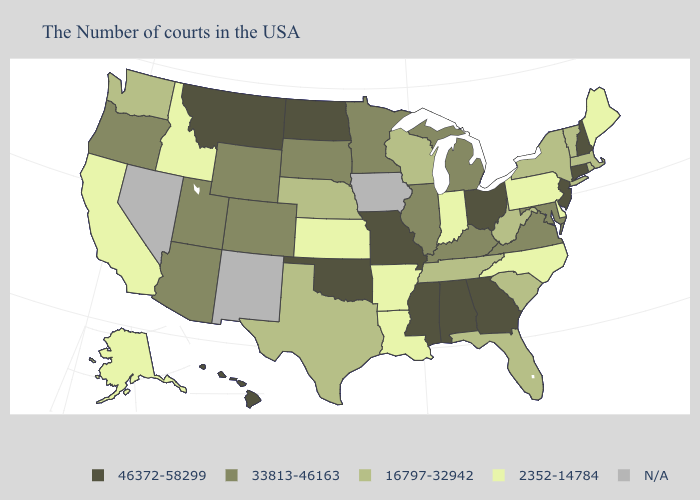Name the states that have a value in the range N/A?
Give a very brief answer. Iowa, New Mexico, Nevada. What is the value of Tennessee?
Quick response, please. 16797-32942. What is the lowest value in states that border Florida?
Concise answer only. 46372-58299. What is the value of Michigan?
Be succinct. 33813-46163. What is the value of Delaware?
Give a very brief answer. 2352-14784. Which states hav the highest value in the South?
Short answer required. Georgia, Alabama, Mississippi, Oklahoma. Name the states that have a value in the range 46372-58299?
Quick response, please. New Hampshire, Connecticut, New Jersey, Ohio, Georgia, Alabama, Mississippi, Missouri, Oklahoma, North Dakota, Montana, Hawaii. What is the highest value in states that border North Carolina?
Answer briefly. 46372-58299. Does Idaho have the lowest value in the West?
Keep it brief. Yes. Name the states that have a value in the range 46372-58299?
Quick response, please. New Hampshire, Connecticut, New Jersey, Ohio, Georgia, Alabama, Mississippi, Missouri, Oklahoma, North Dakota, Montana, Hawaii. Does the first symbol in the legend represent the smallest category?
Keep it brief. No. Does Indiana have the highest value in the MidWest?
Give a very brief answer. No. What is the lowest value in the USA?
Answer briefly. 2352-14784. Among the states that border Louisiana , which have the highest value?
Be succinct. Mississippi. Name the states that have a value in the range 16797-32942?
Concise answer only. Massachusetts, Rhode Island, Vermont, New York, South Carolina, West Virginia, Florida, Tennessee, Wisconsin, Nebraska, Texas, Washington. 